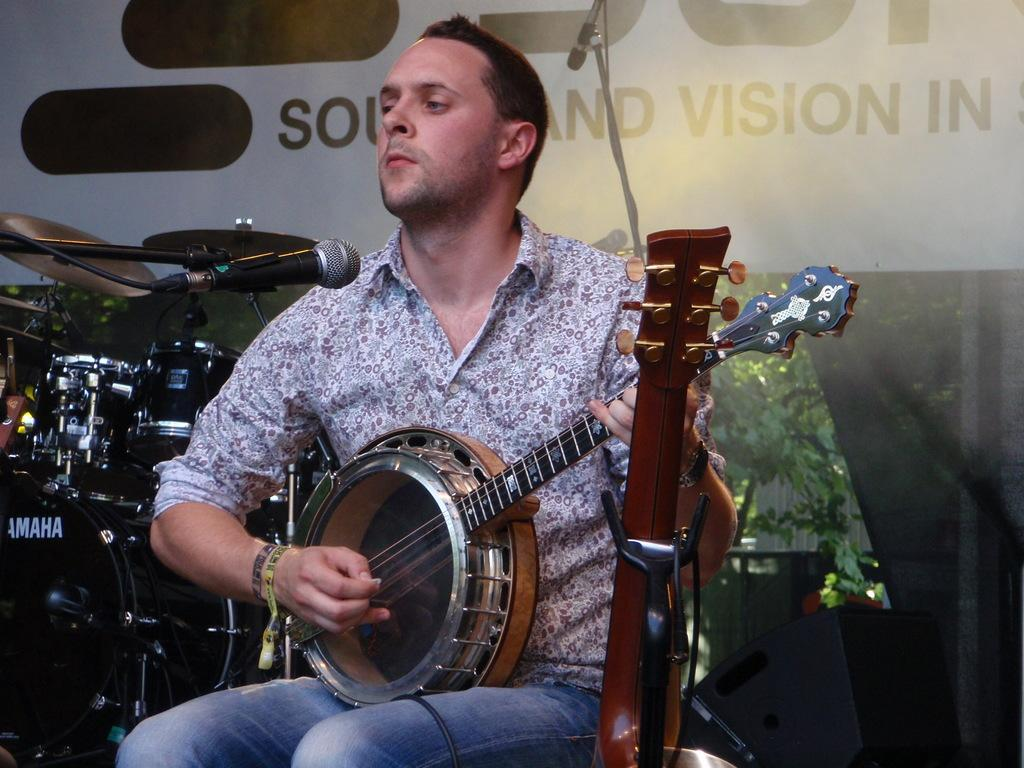Who is the main subject in the image? There is a man in the image. What is the man doing in the image? The man is playing a musical instrument. What is the man sitting on in the image? The man is sitting on a chair. What type of clothing is the man wearing on his upper body? The man is wearing a shirt. What type of clothing is the man wearing on his lower body? The man is wearing jeans. What type of writing is the man helping the government with in the image? There is no indication in the image that the man is helping the government or engaging in any writing activities. 